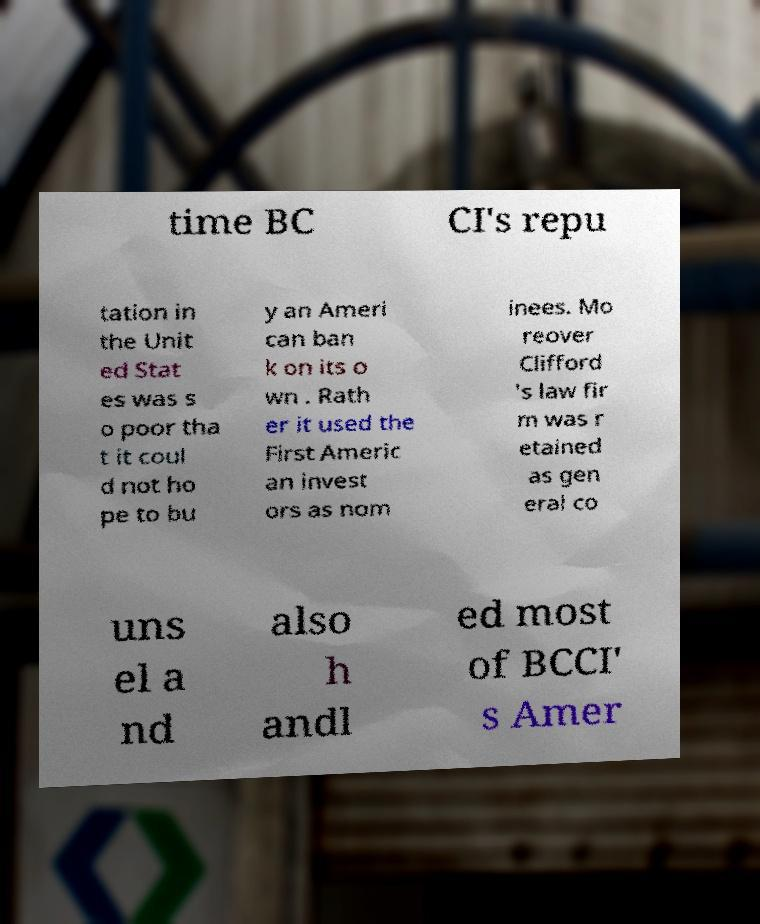For documentation purposes, I need the text within this image transcribed. Could you provide that? time BC CI's repu tation in the Unit ed Stat es was s o poor tha t it coul d not ho pe to bu y an Ameri can ban k on its o wn . Rath er it used the First Americ an invest ors as nom inees. Mo reover Clifford 's law fir m was r etained as gen eral co uns el a nd also h andl ed most of BCCI' s Amer 